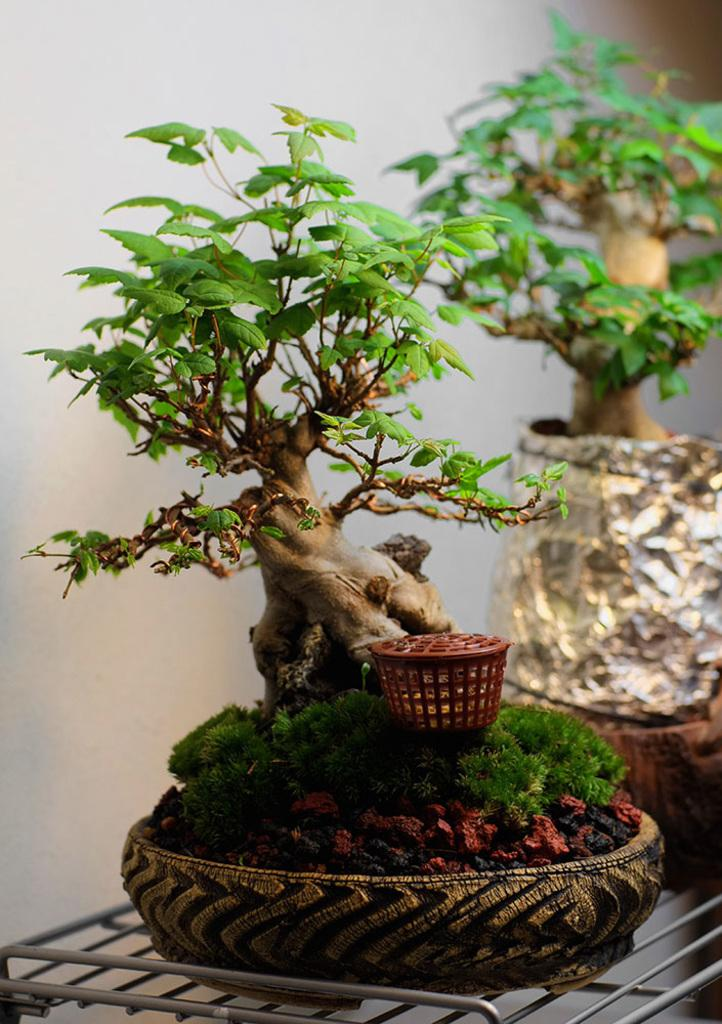What objects are on the table in the image? There are flower pots on the table in the image. What is inside the flower pots? There are plants in the flower pots. What color is the background of the image? The background of the image is white. What type of sound can be heard coming from the plants in the image? There is no sound coming from the plants in the image, as plants do not produce sound. 